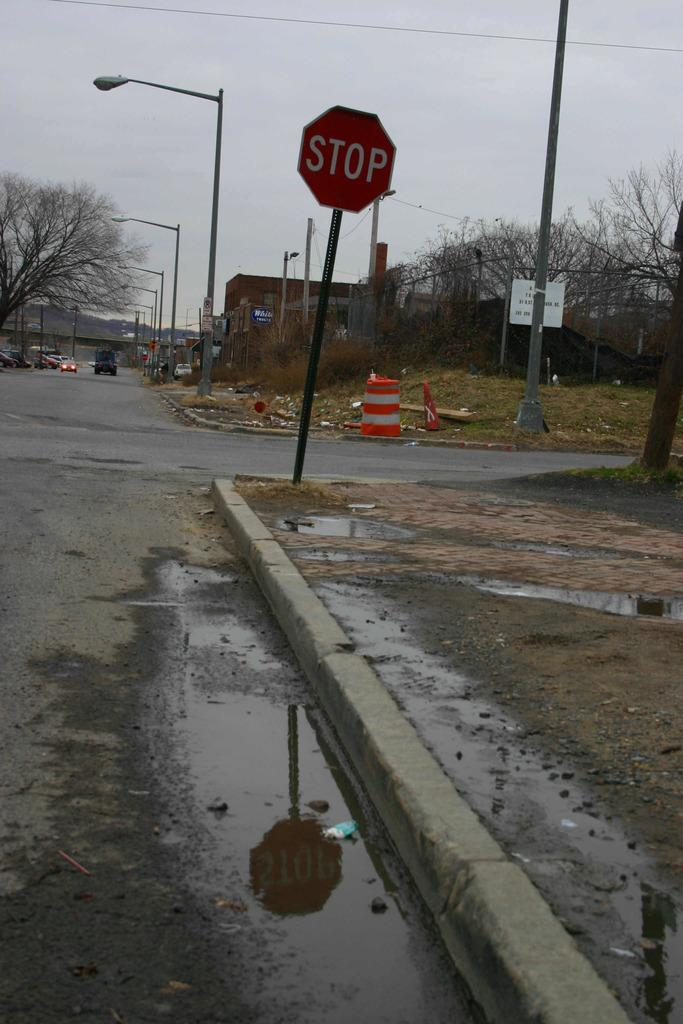<image>
Create a compact narrative representing the image presented. On a wet street standing in the mud is a red stop sign. 